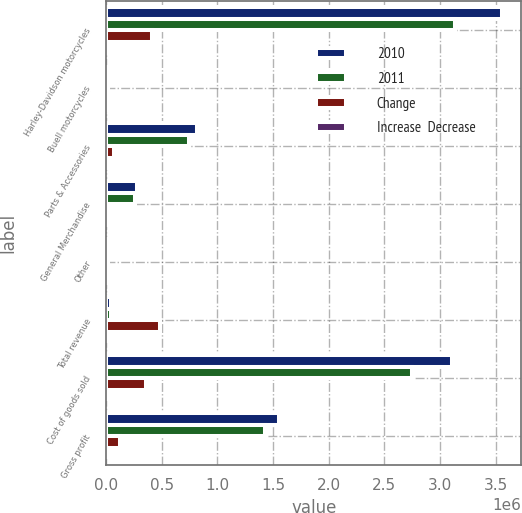Convert chart. <chart><loc_0><loc_0><loc_500><loc_500><stacked_bar_chart><ecel><fcel>Harley-Davidson motorcycles<fcel>Buell motorcycles<fcel>Parts & Accessories<fcel>General Merchandise<fcel>Other<fcel>Total revenue<fcel>Cost of goods sold<fcel>Gross profit<nl><fcel>2010<fcel>3.55329e+06<fcel>1256<fcel>816569<fcel>274124<fcel>17024<fcel>42176.5<fcel>3.10629e+06<fcel>1.55598e+06<nl><fcel>2011<fcel>3.13699e+06<fcel>16280<fcel>749240<fcel>259125<fcel>14995<fcel>42176.5<fcel>2.74922e+06<fcel>1.4274e+06<nl><fcel>Change<fcel>416304<fcel>15024<fcel>67329<fcel>14999<fcel>2029<fcel>485637<fcel>357064<fcel>128573<nl><fcel>Increase  Decrease<fcel>13.3<fcel>92.3<fcel>9<fcel>5.8<fcel>13.5<fcel>11.6<fcel>13<fcel>9<nl></chart> 